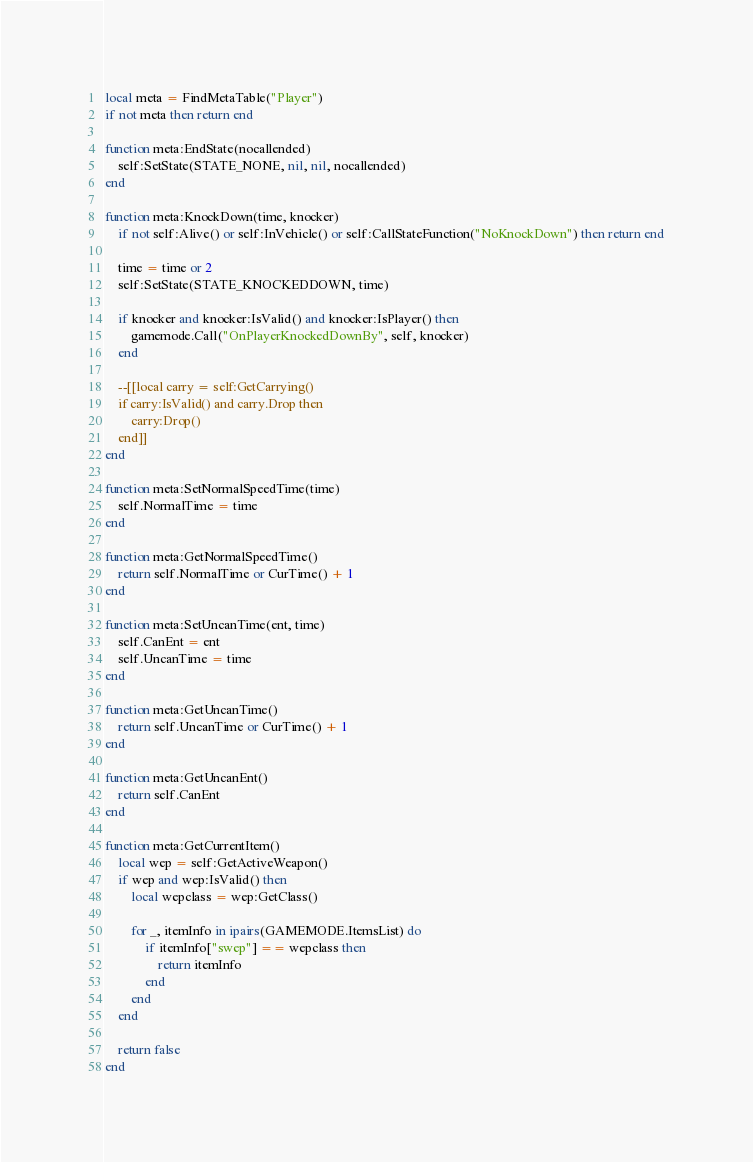Convert code to text. <code><loc_0><loc_0><loc_500><loc_500><_Lua_>local meta = FindMetaTable("Player")
if not meta then return end

function meta:EndState(nocallended)
	self:SetState(STATE_NONE, nil, nil, nocallended)
end

function meta:KnockDown(time, knocker)
	if not self:Alive() or self:InVehicle() or self:CallStateFunction("NoKnockDown") then return end

	time = time or 2
	self:SetState(STATE_KNOCKEDDOWN, time)

	if knocker and knocker:IsValid() and knocker:IsPlayer() then
		gamemode.Call("OnPlayerKnockedDownBy", self, knocker)
	end

	--[[local carry = self:GetCarrying()
	if carry:IsValid() and carry.Drop then
		carry:Drop()
	end]]
end

function meta:SetNormalSpeedTime(time)
	self.NormalTime = time
end

function meta:GetNormalSpeedTime()
	return self.NormalTime or CurTime() + 1
end

function meta:SetUncanTime(ent, time)
	self.CanEnt = ent
	self.UncanTime = time
end

function meta:GetUncanTime()
	return self.UncanTime or CurTime() + 1
end

function meta:GetUncanEnt()
	return self.CanEnt
end

function meta:GetCurrentItem()
	local wep = self:GetActiveWeapon()
	if wep and wep:IsValid() then
		local wepclass = wep:GetClass()

		for _, itemInfo in ipairs(GAMEMODE.ItemsList) do
			if itemInfo["swep"] == wepclass then
				return itemInfo
			end
		end
	end

	return false
end
</code> 